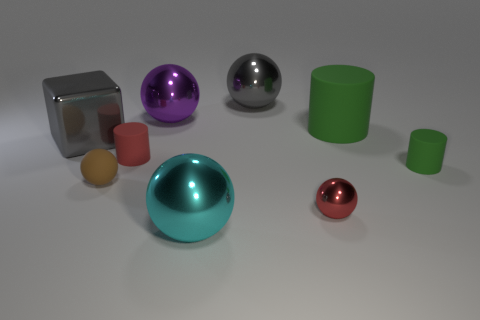Do the tiny red object that is in front of the red matte thing and the big purple object have the same shape?
Your response must be concise. Yes. What is the material of the ball that is the same color as the cube?
Provide a short and direct response. Metal. How many other things are there of the same color as the metal cube?
Keep it short and to the point. 1. Is the size of the gray metal cube the same as the green rubber cylinder to the right of the big green matte thing?
Keep it short and to the point. No. There is a green matte thing to the left of the small rubber cylinder that is on the right side of the cyan metal sphere; how big is it?
Offer a very short reply. Large. What is the color of the big object that is the same shape as the small green matte object?
Give a very brief answer. Green. Do the purple shiny thing and the brown rubber thing have the same size?
Give a very brief answer. No. Are there an equal number of small shiny things behind the large gray cube and big purple objects?
Ensure brevity in your answer.  No. Are there any shiny cubes right of the sphere behind the purple metallic object?
Give a very brief answer. No. There is a gray cube behind the tiny rubber cylinder left of the small ball on the right side of the gray sphere; what size is it?
Your answer should be very brief. Large. 